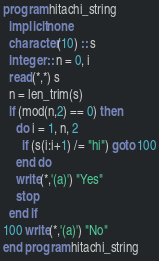Convert code to text. <code><loc_0><loc_0><loc_500><loc_500><_FORTRAN_>program hitachi_string
  implicit none
  character(10) :: s
  integer :: n = 0, i
  read(*,*) s
  n = len_trim(s)
  if (mod(n,2) == 0) then
    do i = 1, n, 2
      if (s(i:i+1) /= "hi") goto 100
    end do
    write(*,'(a)') "Yes"
    stop
  end if
100 write(*,'(a)') "No"
end program hitachi_string</code> 